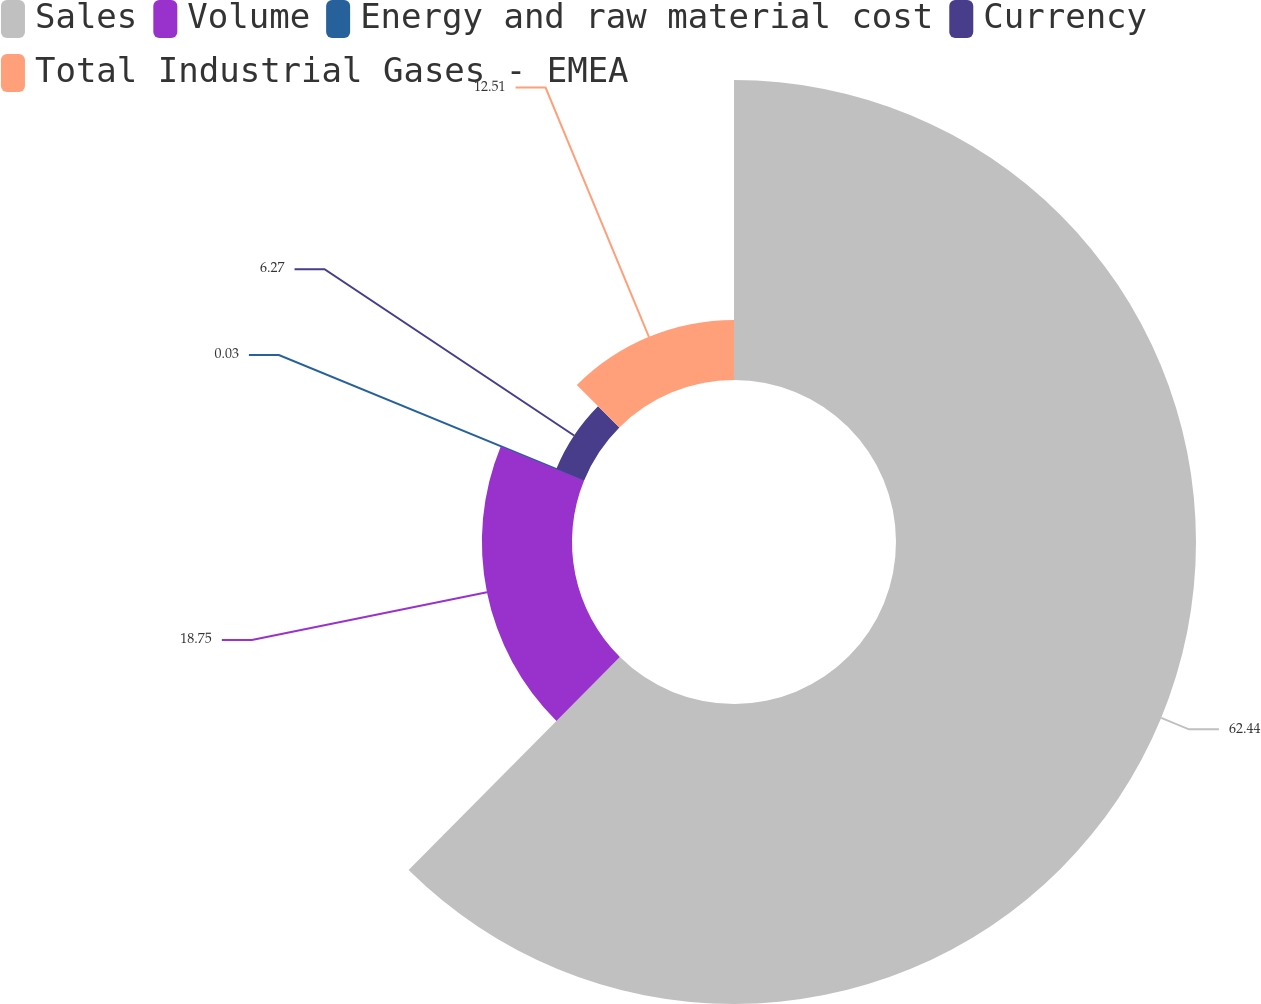Convert chart to OTSL. <chart><loc_0><loc_0><loc_500><loc_500><pie_chart><fcel>Sales<fcel>Volume<fcel>Energy and raw material cost<fcel>Currency<fcel>Total Industrial Gases - EMEA<nl><fcel>62.43%<fcel>18.75%<fcel>0.03%<fcel>6.27%<fcel>12.51%<nl></chart> 